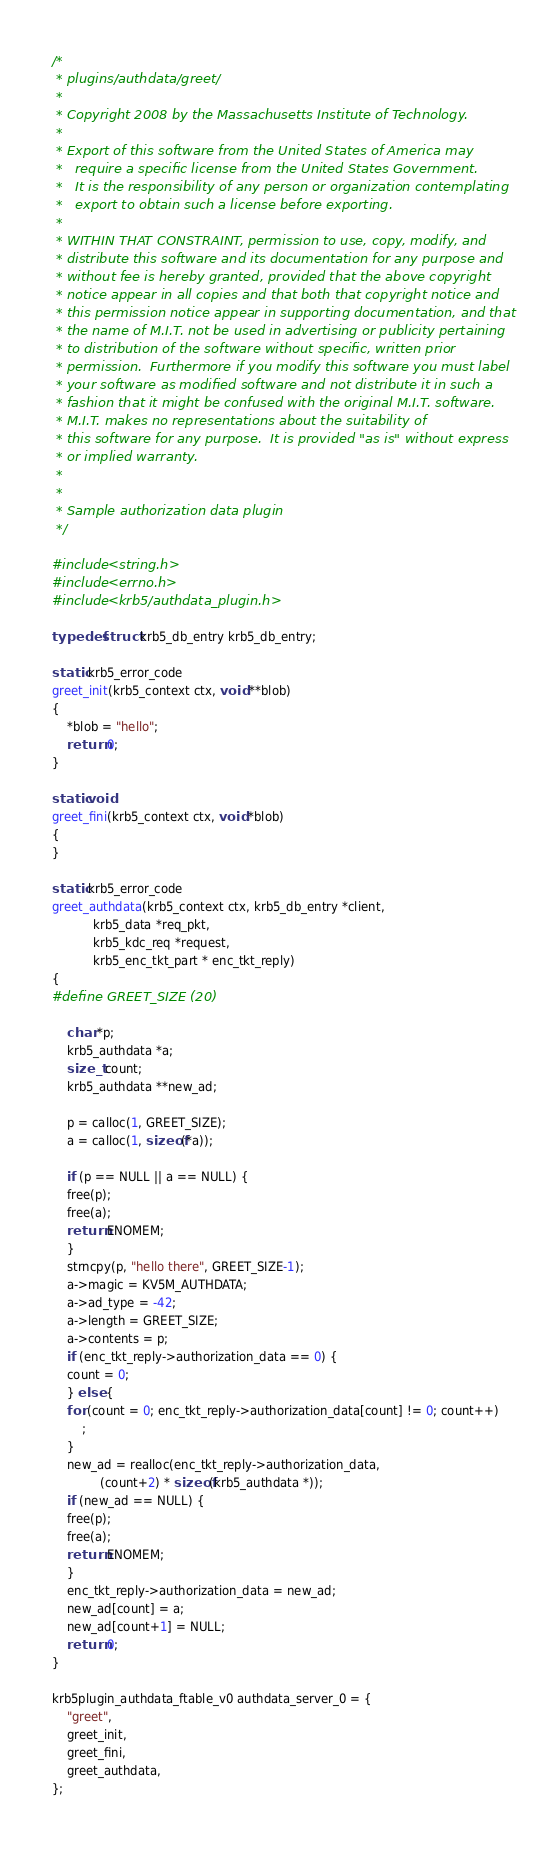Convert code to text. <code><loc_0><loc_0><loc_500><loc_500><_C_>/*
 * plugins/authdata/greet/
 *
 * Copyright 2008 by the Massachusetts Institute of Technology.
 *
 * Export of this software from the United States of America may
 *   require a specific license from the United States Government.
 *   It is the responsibility of any person or organization contemplating
 *   export to obtain such a license before exporting.
 * 
 * WITHIN THAT CONSTRAINT, permission to use, copy, modify, and
 * distribute this software and its documentation for any purpose and
 * without fee is hereby granted, provided that the above copyright
 * notice appear in all copies and that both that copyright notice and
 * this permission notice appear in supporting documentation, and that
 * the name of M.I.T. not be used in advertising or publicity pertaining
 * to distribution of the software without specific, written prior
 * permission.  Furthermore if you modify this software you must label
 * your software as modified software and not distribute it in such a
 * fashion that it might be confused with the original M.I.T. software.
 * M.I.T. makes no representations about the suitability of
 * this software for any purpose.  It is provided "as is" without express
 * or implied warranty.
 * 
 *
 * Sample authorization data plugin
 */

#include <string.h>
#include <errno.h>
#include <krb5/authdata_plugin.h>

typedef struct krb5_db_entry krb5_db_entry;

static krb5_error_code
greet_init(krb5_context ctx, void **blob)
{
    *blob = "hello";
    return 0;
}

static void
greet_fini(krb5_context ctx, void *blob)
{
}

static krb5_error_code
greet_authdata(krb5_context ctx, krb5_db_entry *client,
	       krb5_data *req_pkt,
	       krb5_kdc_req *request,
	       krb5_enc_tkt_part * enc_tkt_reply)
{
#define GREET_SIZE (20)

    char *p;
    krb5_authdata *a;
    size_t count;
    krb5_authdata **new_ad;

    p = calloc(1, GREET_SIZE);
    a = calloc(1, sizeof(*a));

    if (p == NULL || a == NULL) {
	free(p);
	free(a);
	return ENOMEM;
    }
    strncpy(p, "hello there", GREET_SIZE-1);
    a->magic = KV5M_AUTHDATA;
    a->ad_type = -42;
    a->length = GREET_SIZE;
    a->contents = p;
    if (enc_tkt_reply->authorization_data == 0) {
	count = 0;
    } else {
	for (count = 0; enc_tkt_reply->authorization_data[count] != 0; count++)
	    ;
    }
    new_ad = realloc(enc_tkt_reply->authorization_data,
		     (count+2) * sizeof(krb5_authdata *));
    if (new_ad == NULL) {
	free(p);
	free(a);
	return ENOMEM;
    }
    enc_tkt_reply->authorization_data = new_ad;
    new_ad[count] = a;
    new_ad[count+1] = NULL;
    return 0;
}

krb5plugin_authdata_ftable_v0 authdata_server_0 = {
    "greet",
    greet_init,
    greet_fini,
    greet_authdata,
};
</code> 